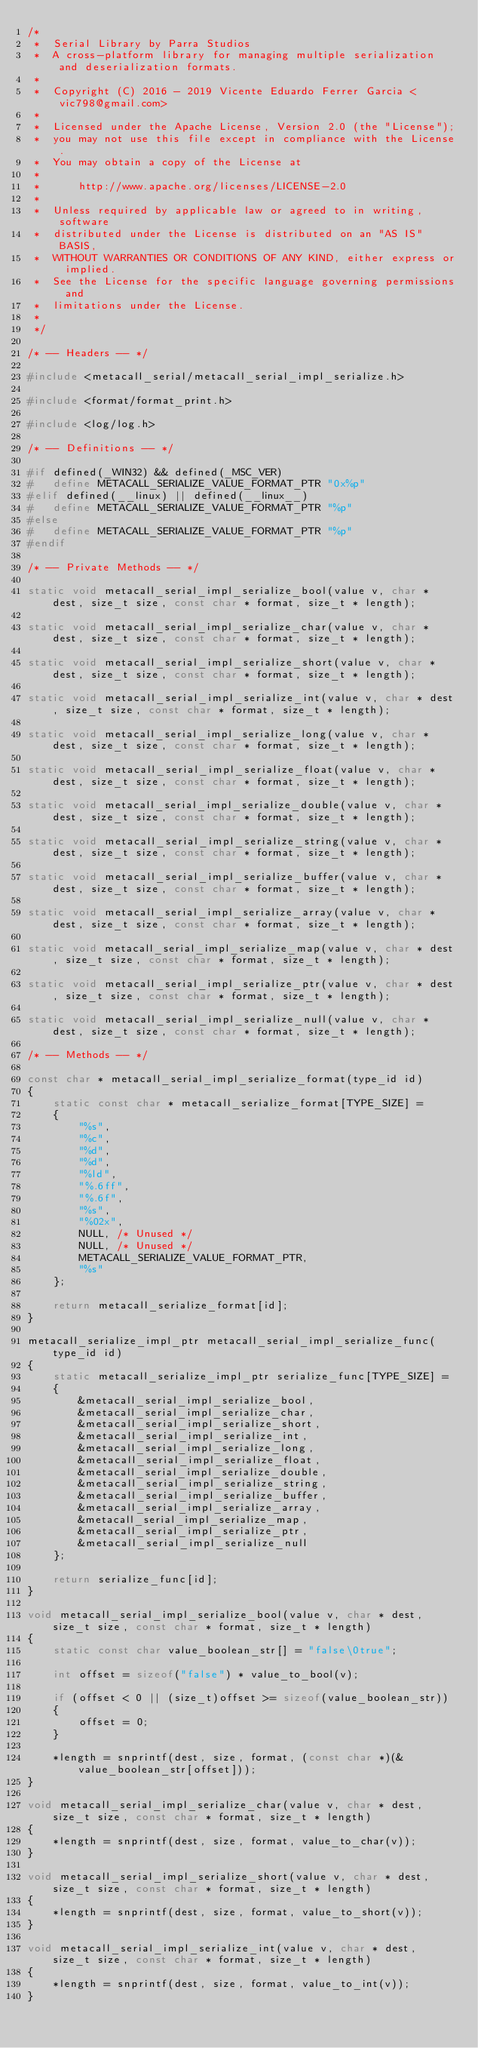Convert code to text. <code><loc_0><loc_0><loc_500><loc_500><_C_>/*
 *	Serial Library by Parra Studios
 *	A cross-platform library for managing multiple serialization and deserialization formats.
 *
 *	Copyright (C) 2016 - 2019 Vicente Eduardo Ferrer Garcia <vic798@gmail.com>
 *
 *	Licensed under the Apache License, Version 2.0 (the "License");
 *	you may not use this file except in compliance with the License.
 *	You may obtain a copy of the License at
 *
 *		http://www.apache.org/licenses/LICENSE-2.0
 *
 *	Unless required by applicable law or agreed to in writing, software
 *	distributed under the License is distributed on an "AS IS" BASIS,
 *	WITHOUT WARRANTIES OR CONDITIONS OF ANY KIND, either express or implied.
 *	See the License for the specific language governing permissions and
 *	limitations under the License.
 *
 */

/* -- Headers -- */

#include <metacall_serial/metacall_serial_impl_serialize.h>

#include <format/format_print.h>

#include <log/log.h>

/* -- Definitions -- */

#if defined(_WIN32) && defined(_MSC_VER)
#	define METACALL_SERIALIZE_VALUE_FORMAT_PTR "0x%p"
#elif defined(__linux) || defined(__linux__)
#	define METACALL_SERIALIZE_VALUE_FORMAT_PTR "%p"
#else
#	define METACALL_SERIALIZE_VALUE_FORMAT_PTR "%p"
#endif

/* -- Private Methods -- */

static void metacall_serial_impl_serialize_bool(value v, char * dest, size_t size, const char * format, size_t * length);

static void metacall_serial_impl_serialize_char(value v, char * dest, size_t size, const char * format, size_t * length);

static void metacall_serial_impl_serialize_short(value v, char * dest, size_t size, const char * format, size_t * length);

static void metacall_serial_impl_serialize_int(value v, char * dest, size_t size, const char * format, size_t * length);

static void metacall_serial_impl_serialize_long(value v, char * dest, size_t size, const char * format, size_t * length);

static void metacall_serial_impl_serialize_float(value v, char * dest, size_t size, const char * format, size_t * length);

static void metacall_serial_impl_serialize_double(value v, char * dest, size_t size, const char * format, size_t * length);

static void metacall_serial_impl_serialize_string(value v, char * dest, size_t size, const char * format, size_t * length);

static void metacall_serial_impl_serialize_buffer(value v, char * dest, size_t size, const char * format, size_t * length);

static void metacall_serial_impl_serialize_array(value v, char * dest, size_t size, const char * format, size_t * length);

static void metacall_serial_impl_serialize_map(value v, char * dest, size_t size, const char * format, size_t * length);

static void metacall_serial_impl_serialize_ptr(value v, char * dest, size_t size, const char * format, size_t * length);

static void metacall_serial_impl_serialize_null(value v, char * dest, size_t size, const char * format, size_t * length);

/* -- Methods -- */

const char * metacall_serial_impl_serialize_format(type_id id)
{
	static const char * metacall_serialize_format[TYPE_SIZE] =
	{
		"%s",
		"%c",
		"%d",
		"%d",
		"%ld",
		"%.6ff",
		"%.6f",
		"%s",
		"%02x",
		NULL, /* Unused */
		NULL, /* Unused */
		METACALL_SERIALIZE_VALUE_FORMAT_PTR,
		"%s"
	};

	return metacall_serialize_format[id];
}

metacall_serialize_impl_ptr metacall_serial_impl_serialize_func(type_id id)
{
	static metacall_serialize_impl_ptr serialize_func[TYPE_SIZE] =
	{
		&metacall_serial_impl_serialize_bool,
		&metacall_serial_impl_serialize_char,
		&metacall_serial_impl_serialize_short,
		&metacall_serial_impl_serialize_int,
		&metacall_serial_impl_serialize_long,
		&metacall_serial_impl_serialize_float,
		&metacall_serial_impl_serialize_double,
		&metacall_serial_impl_serialize_string,
		&metacall_serial_impl_serialize_buffer,
		&metacall_serial_impl_serialize_array,
		&metacall_serial_impl_serialize_map,
		&metacall_serial_impl_serialize_ptr,
		&metacall_serial_impl_serialize_null
	};

	return serialize_func[id];
}

void metacall_serial_impl_serialize_bool(value v, char * dest, size_t size, const char * format, size_t * length)
{
	static const char value_boolean_str[] = "false\0true";

	int offset = sizeof("false") * value_to_bool(v);

	if (offset < 0 || (size_t)offset >= sizeof(value_boolean_str))
	{
		offset = 0;
	}

	*length = snprintf(dest, size, format, (const char *)(&value_boolean_str[offset]));
}

void metacall_serial_impl_serialize_char(value v, char * dest, size_t size, const char * format, size_t * length)
{
	*length = snprintf(dest, size, format, value_to_char(v));
}

void metacall_serial_impl_serialize_short(value v, char * dest, size_t size, const char * format, size_t * length)
{
	*length = snprintf(dest, size, format, value_to_short(v));
}

void metacall_serial_impl_serialize_int(value v, char * dest, size_t size, const char * format, size_t * length)
{
	*length = snprintf(dest, size, format, value_to_int(v));
}
</code> 